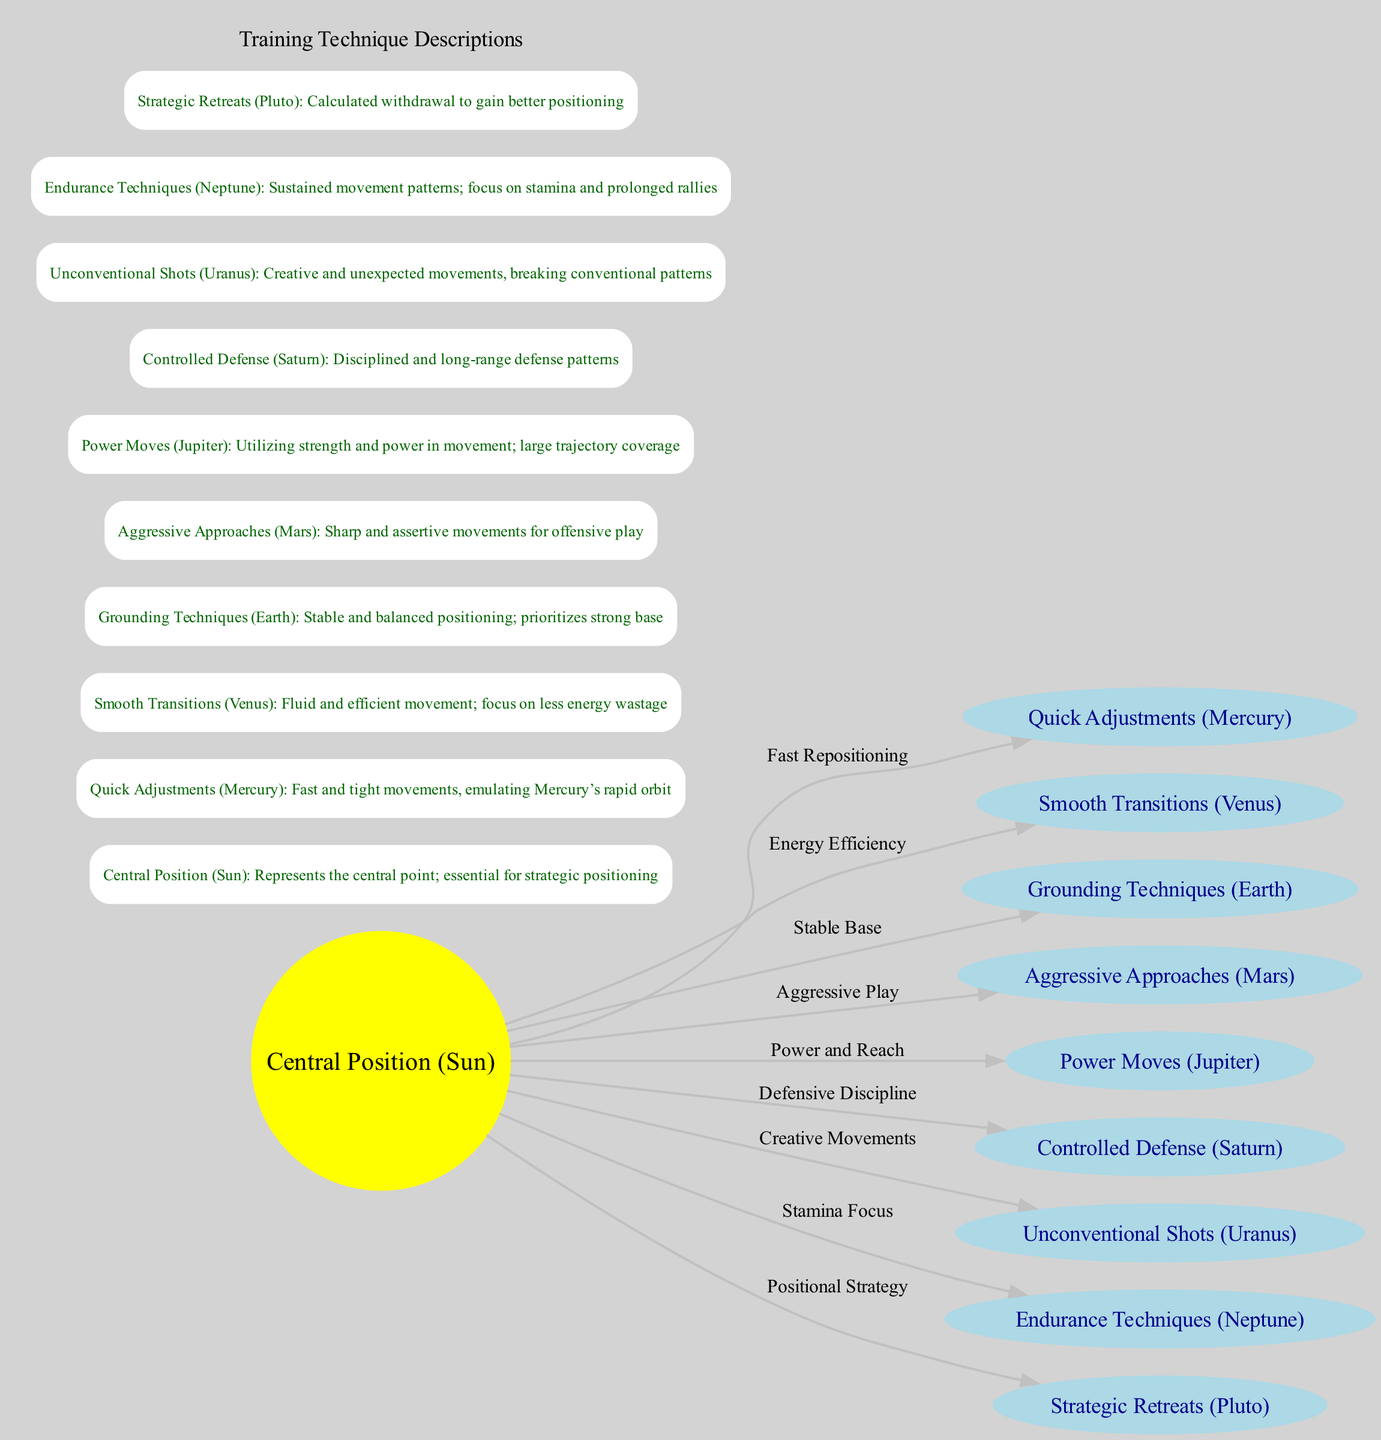What is represented by the "Central Position" node? The "Central Position" node, labeled as "Sun", represents the essential central point for strategic positioning on the tennis court, as indicated in its description.
Answer: Central Position (Sun) How many nodes are in the diagram? The diagram includes a total of 10 nodes, as each celestial body and the central position are counted. This includes the sun and the nine planets listed.
Answer: 10 What does the edge labeled "Fast Repositioning" connect? The edge labeled "Fast Repositioning" connects the "Central Position (Sun)" node to the "Quick Adjustments (Mercury)" node, showing the relationship between strategic positioning and quick movement adjustments.
Answer: Central Position (Sun) to Quick Adjustments (Mercury) Which node focuses on "Sustained movement patterns"? The node that focuses on "Sustained movement patterns; focus on stamina and prolonged rallies" is labeled as "Endurance Techniques (Neptune)", clearly indicated in its description.
Answer: Endurance Techniques (Neptune) Which node is associated with "Calcuated withdrawal to gain better positioning"? The node associated with "Calculated withdrawal to gain better positioning" is labeled "Strategic Retreats (Pluto)", as per its specific description in the diagram.
Answer: Strategic Retreats (Pluto) How many edges lead from the "Central Position (Sun)"? There are 9 edges leading from the "Central Position (Sun)", connecting it to all other nodes representing various training techniques.
Answer: 9 What does the node "Aggressive Approaches (Mars)" emphasize? The node "Aggressive Approaches (Mars)" emphasizes "Sharp and assertive movements for offensive play", as detailed in its description, indicating its focus on aggressive techniques.
Answer: Sharp and assertive movements for offensive play Which training technique is linked to "Creative and unexpected movements"? The training technique linked to "Creative and unexpected movements" is the "Unconventional Shots (Uranus)", which encourages innovative play styles and movement patterns.
Answer: Unconventional Shots (Uranus) What is the purpose of the edge connecting "Sun" to "Saturn"? The edge connects "Sun" to "Controlled Defense (Saturn)", indicating a relationship labeled "Defensive Discipline", showcasing the link between central positioning and disciplined defense strategies.
Answer: Defensive Discipline 